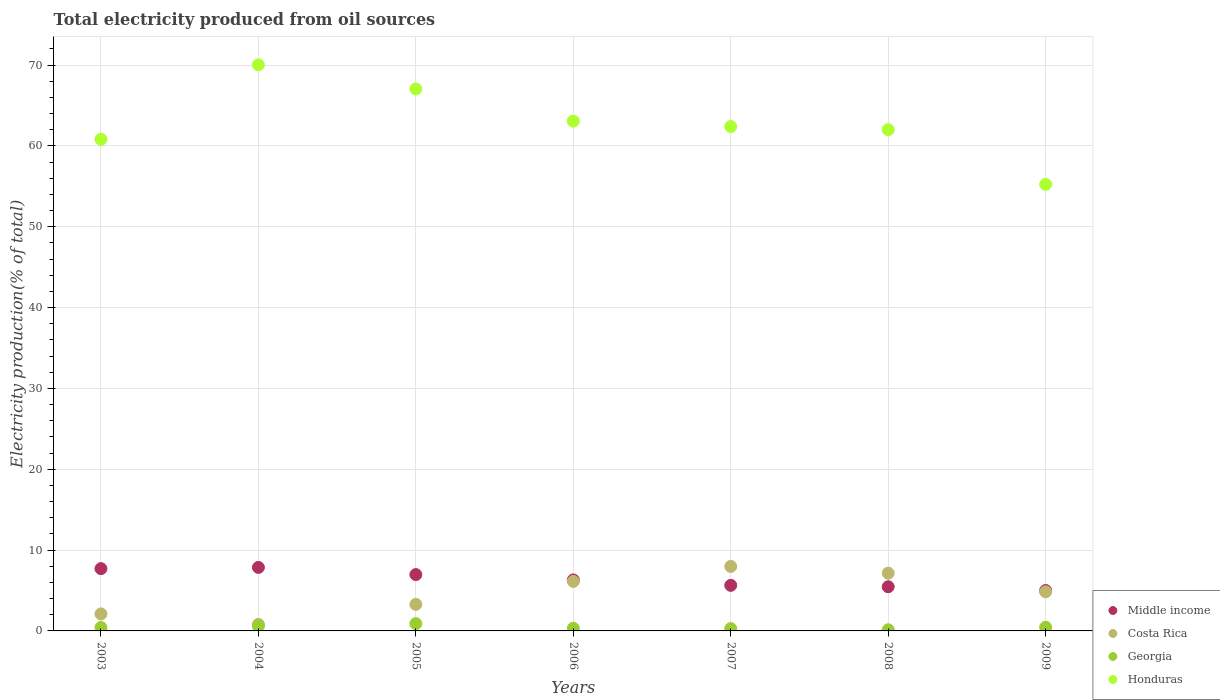Is the number of dotlines equal to the number of legend labels?
Your response must be concise. Yes. What is the total electricity produced in Georgia in 2005?
Your answer should be compact. 0.91. Across all years, what is the maximum total electricity produced in Costa Rica?
Your response must be concise. 7.98. Across all years, what is the minimum total electricity produced in Costa Rica?
Give a very brief answer. 0.8. In which year was the total electricity produced in Georgia minimum?
Provide a succinct answer. 2008. What is the total total electricity produced in Georgia in the graph?
Your answer should be very brief. 3.15. What is the difference between the total electricity produced in Georgia in 2004 and that in 2005?
Make the answer very short. -0.3. What is the difference between the total electricity produced in Costa Rica in 2003 and the total electricity produced in Middle income in 2007?
Give a very brief answer. -3.53. What is the average total electricity produced in Honduras per year?
Your answer should be very brief. 62.95. In the year 2003, what is the difference between the total electricity produced in Honduras and total electricity produced in Middle income?
Your answer should be compact. 53.12. In how many years, is the total electricity produced in Honduras greater than 10 %?
Ensure brevity in your answer.  7. What is the ratio of the total electricity produced in Costa Rica in 2004 to that in 2008?
Your answer should be very brief. 0.11. What is the difference between the highest and the second highest total electricity produced in Middle income?
Your answer should be very brief. 0.15. What is the difference between the highest and the lowest total electricity produced in Middle income?
Provide a succinct answer. 2.85. In how many years, is the total electricity produced in Middle income greater than the average total electricity produced in Middle income taken over all years?
Offer a very short reply. 3. Is it the case that in every year, the sum of the total electricity produced in Middle income and total electricity produced in Honduras  is greater than the sum of total electricity produced in Georgia and total electricity produced in Costa Rica?
Give a very brief answer. Yes. Does the total electricity produced in Georgia monotonically increase over the years?
Provide a short and direct response. No. Is the total electricity produced in Costa Rica strictly less than the total electricity produced in Honduras over the years?
Give a very brief answer. Yes. How many dotlines are there?
Your answer should be compact. 4. Are the values on the major ticks of Y-axis written in scientific E-notation?
Make the answer very short. No. Does the graph contain any zero values?
Provide a succinct answer. No. Does the graph contain grids?
Give a very brief answer. Yes. Where does the legend appear in the graph?
Your answer should be compact. Bottom right. How many legend labels are there?
Your answer should be compact. 4. How are the legend labels stacked?
Your answer should be compact. Vertical. What is the title of the graph?
Your answer should be compact. Total electricity produced from oil sources. What is the label or title of the X-axis?
Offer a terse response. Years. What is the Electricity production(% of total) in Middle income in 2003?
Your response must be concise. 7.7. What is the Electricity production(% of total) in Costa Rica in 2003?
Offer a very short reply. 2.11. What is the Electricity production(% of total) in Georgia in 2003?
Ensure brevity in your answer.  0.42. What is the Electricity production(% of total) in Honduras in 2003?
Offer a terse response. 60.82. What is the Electricity production(% of total) in Middle income in 2004?
Offer a very short reply. 7.86. What is the Electricity production(% of total) in Costa Rica in 2004?
Ensure brevity in your answer.  0.8. What is the Electricity production(% of total) in Georgia in 2004?
Your answer should be compact. 0.61. What is the Electricity production(% of total) in Honduras in 2004?
Your answer should be very brief. 70.03. What is the Electricity production(% of total) of Middle income in 2005?
Offer a terse response. 6.97. What is the Electricity production(% of total) of Costa Rica in 2005?
Make the answer very short. 3.28. What is the Electricity production(% of total) of Georgia in 2005?
Provide a succinct answer. 0.91. What is the Electricity production(% of total) of Honduras in 2005?
Your answer should be compact. 67.05. What is the Electricity production(% of total) in Middle income in 2006?
Your answer should be compact. 6.31. What is the Electricity production(% of total) in Costa Rica in 2006?
Provide a succinct answer. 6.13. What is the Electricity production(% of total) in Georgia in 2006?
Provide a succinct answer. 0.33. What is the Electricity production(% of total) in Honduras in 2006?
Offer a terse response. 63.07. What is the Electricity production(% of total) in Middle income in 2007?
Ensure brevity in your answer.  5.64. What is the Electricity production(% of total) of Costa Rica in 2007?
Offer a very short reply. 7.98. What is the Electricity production(% of total) in Georgia in 2007?
Your answer should be compact. 0.29. What is the Electricity production(% of total) of Honduras in 2007?
Keep it short and to the point. 62.4. What is the Electricity production(% of total) in Middle income in 2008?
Your answer should be compact. 5.47. What is the Electricity production(% of total) of Costa Rica in 2008?
Your answer should be very brief. 7.15. What is the Electricity production(% of total) in Georgia in 2008?
Your answer should be very brief. 0.14. What is the Electricity production(% of total) of Honduras in 2008?
Give a very brief answer. 62.01. What is the Electricity production(% of total) in Middle income in 2009?
Make the answer very short. 5. What is the Electricity production(% of total) of Costa Rica in 2009?
Your response must be concise. 4.84. What is the Electricity production(% of total) of Georgia in 2009?
Your response must be concise. 0.46. What is the Electricity production(% of total) in Honduras in 2009?
Offer a terse response. 55.25. Across all years, what is the maximum Electricity production(% of total) in Middle income?
Offer a terse response. 7.86. Across all years, what is the maximum Electricity production(% of total) in Costa Rica?
Ensure brevity in your answer.  7.98. Across all years, what is the maximum Electricity production(% of total) in Georgia?
Ensure brevity in your answer.  0.91. Across all years, what is the maximum Electricity production(% of total) in Honduras?
Your answer should be compact. 70.03. Across all years, what is the minimum Electricity production(% of total) in Middle income?
Offer a terse response. 5. Across all years, what is the minimum Electricity production(% of total) of Costa Rica?
Provide a succinct answer. 0.8. Across all years, what is the minimum Electricity production(% of total) in Georgia?
Provide a short and direct response. 0.14. Across all years, what is the minimum Electricity production(% of total) of Honduras?
Keep it short and to the point. 55.25. What is the total Electricity production(% of total) of Middle income in the graph?
Your response must be concise. 44.95. What is the total Electricity production(% of total) of Costa Rica in the graph?
Give a very brief answer. 32.29. What is the total Electricity production(% of total) in Georgia in the graph?
Offer a terse response. 3.15. What is the total Electricity production(% of total) in Honduras in the graph?
Your response must be concise. 440.64. What is the difference between the Electricity production(% of total) in Middle income in 2003 and that in 2004?
Ensure brevity in your answer.  -0.15. What is the difference between the Electricity production(% of total) of Costa Rica in 2003 and that in 2004?
Make the answer very short. 1.3. What is the difference between the Electricity production(% of total) of Georgia in 2003 and that in 2004?
Make the answer very short. -0.19. What is the difference between the Electricity production(% of total) of Honduras in 2003 and that in 2004?
Your answer should be very brief. -9.21. What is the difference between the Electricity production(% of total) in Middle income in 2003 and that in 2005?
Your answer should be compact. 0.73. What is the difference between the Electricity production(% of total) in Costa Rica in 2003 and that in 2005?
Provide a short and direct response. -1.17. What is the difference between the Electricity production(% of total) of Georgia in 2003 and that in 2005?
Provide a succinct answer. -0.49. What is the difference between the Electricity production(% of total) in Honduras in 2003 and that in 2005?
Offer a terse response. -6.23. What is the difference between the Electricity production(% of total) in Middle income in 2003 and that in 2006?
Ensure brevity in your answer.  1.4. What is the difference between the Electricity production(% of total) in Costa Rica in 2003 and that in 2006?
Give a very brief answer. -4.02. What is the difference between the Electricity production(% of total) of Georgia in 2003 and that in 2006?
Make the answer very short. 0.09. What is the difference between the Electricity production(% of total) of Honduras in 2003 and that in 2006?
Provide a succinct answer. -2.25. What is the difference between the Electricity production(% of total) of Middle income in 2003 and that in 2007?
Keep it short and to the point. 2.07. What is the difference between the Electricity production(% of total) of Costa Rica in 2003 and that in 2007?
Keep it short and to the point. -5.87. What is the difference between the Electricity production(% of total) of Georgia in 2003 and that in 2007?
Provide a succinct answer. 0.13. What is the difference between the Electricity production(% of total) in Honduras in 2003 and that in 2007?
Offer a very short reply. -1.57. What is the difference between the Electricity production(% of total) in Middle income in 2003 and that in 2008?
Ensure brevity in your answer.  2.24. What is the difference between the Electricity production(% of total) in Costa Rica in 2003 and that in 2008?
Provide a succinct answer. -5.04. What is the difference between the Electricity production(% of total) of Georgia in 2003 and that in 2008?
Provide a succinct answer. 0.28. What is the difference between the Electricity production(% of total) in Honduras in 2003 and that in 2008?
Offer a very short reply. -1.19. What is the difference between the Electricity production(% of total) in Middle income in 2003 and that in 2009?
Ensure brevity in your answer.  2.7. What is the difference between the Electricity production(% of total) of Costa Rica in 2003 and that in 2009?
Offer a very short reply. -2.74. What is the difference between the Electricity production(% of total) in Georgia in 2003 and that in 2009?
Offer a terse response. -0.04. What is the difference between the Electricity production(% of total) of Honduras in 2003 and that in 2009?
Keep it short and to the point. 5.58. What is the difference between the Electricity production(% of total) in Middle income in 2004 and that in 2005?
Ensure brevity in your answer.  0.88. What is the difference between the Electricity production(% of total) in Costa Rica in 2004 and that in 2005?
Offer a very short reply. -2.48. What is the difference between the Electricity production(% of total) of Georgia in 2004 and that in 2005?
Your answer should be very brief. -0.3. What is the difference between the Electricity production(% of total) of Honduras in 2004 and that in 2005?
Your answer should be compact. 2.98. What is the difference between the Electricity production(% of total) of Middle income in 2004 and that in 2006?
Make the answer very short. 1.55. What is the difference between the Electricity production(% of total) of Costa Rica in 2004 and that in 2006?
Your answer should be very brief. -5.33. What is the difference between the Electricity production(% of total) in Georgia in 2004 and that in 2006?
Your response must be concise. 0.28. What is the difference between the Electricity production(% of total) in Honduras in 2004 and that in 2006?
Offer a very short reply. 6.96. What is the difference between the Electricity production(% of total) of Middle income in 2004 and that in 2007?
Give a very brief answer. 2.22. What is the difference between the Electricity production(% of total) in Costa Rica in 2004 and that in 2007?
Your response must be concise. -7.17. What is the difference between the Electricity production(% of total) in Georgia in 2004 and that in 2007?
Your response must be concise. 0.32. What is the difference between the Electricity production(% of total) in Honduras in 2004 and that in 2007?
Give a very brief answer. 7.63. What is the difference between the Electricity production(% of total) of Middle income in 2004 and that in 2008?
Your response must be concise. 2.39. What is the difference between the Electricity production(% of total) in Costa Rica in 2004 and that in 2008?
Offer a terse response. -6.34. What is the difference between the Electricity production(% of total) of Georgia in 2004 and that in 2008?
Your answer should be very brief. 0.46. What is the difference between the Electricity production(% of total) in Honduras in 2004 and that in 2008?
Offer a very short reply. 8.02. What is the difference between the Electricity production(% of total) in Middle income in 2004 and that in 2009?
Give a very brief answer. 2.85. What is the difference between the Electricity production(% of total) in Costa Rica in 2004 and that in 2009?
Your response must be concise. -4.04. What is the difference between the Electricity production(% of total) in Georgia in 2004 and that in 2009?
Your answer should be compact. 0.15. What is the difference between the Electricity production(% of total) in Honduras in 2004 and that in 2009?
Make the answer very short. 14.79. What is the difference between the Electricity production(% of total) of Middle income in 2005 and that in 2006?
Provide a short and direct response. 0.66. What is the difference between the Electricity production(% of total) of Costa Rica in 2005 and that in 2006?
Provide a short and direct response. -2.85. What is the difference between the Electricity production(% of total) in Georgia in 2005 and that in 2006?
Make the answer very short. 0.58. What is the difference between the Electricity production(% of total) in Honduras in 2005 and that in 2006?
Ensure brevity in your answer.  3.98. What is the difference between the Electricity production(% of total) of Middle income in 2005 and that in 2007?
Keep it short and to the point. 1.33. What is the difference between the Electricity production(% of total) of Costa Rica in 2005 and that in 2007?
Your answer should be very brief. -4.7. What is the difference between the Electricity production(% of total) in Georgia in 2005 and that in 2007?
Keep it short and to the point. 0.62. What is the difference between the Electricity production(% of total) of Honduras in 2005 and that in 2007?
Make the answer very short. 4.65. What is the difference between the Electricity production(% of total) in Middle income in 2005 and that in 2008?
Your response must be concise. 1.51. What is the difference between the Electricity production(% of total) in Costa Rica in 2005 and that in 2008?
Your answer should be compact. -3.86. What is the difference between the Electricity production(% of total) in Georgia in 2005 and that in 2008?
Offer a very short reply. 0.77. What is the difference between the Electricity production(% of total) of Honduras in 2005 and that in 2008?
Offer a very short reply. 5.04. What is the difference between the Electricity production(% of total) in Middle income in 2005 and that in 2009?
Offer a terse response. 1.97. What is the difference between the Electricity production(% of total) in Costa Rica in 2005 and that in 2009?
Make the answer very short. -1.56. What is the difference between the Electricity production(% of total) in Georgia in 2005 and that in 2009?
Give a very brief answer. 0.45. What is the difference between the Electricity production(% of total) of Honduras in 2005 and that in 2009?
Provide a short and direct response. 11.81. What is the difference between the Electricity production(% of total) in Middle income in 2006 and that in 2007?
Provide a short and direct response. 0.67. What is the difference between the Electricity production(% of total) of Costa Rica in 2006 and that in 2007?
Provide a succinct answer. -1.85. What is the difference between the Electricity production(% of total) in Georgia in 2006 and that in 2007?
Ensure brevity in your answer.  0.04. What is the difference between the Electricity production(% of total) of Honduras in 2006 and that in 2007?
Provide a succinct answer. 0.67. What is the difference between the Electricity production(% of total) of Middle income in 2006 and that in 2008?
Give a very brief answer. 0.84. What is the difference between the Electricity production(% of total) in Costa Rica in 2006 and that in 2008?
Offer a terse response. -1.02. What is the difference between the Electricity production(% of total) in Georgia in 2006 and that in 2008?
Your response must be concise. 0.19. What is the difference between the Electricity production(% of total) of Honduras in 2006 and that in 2008?
Your answer should be very brief. 1.06. What is the difference between the Electricity production(% of total) of Middle income in 2006 and that in 2009?
Provide a short and direct response. 1.3. What is the difference between the Electricity production(% of total) in Costa Rica in 2006 and that in 2009?
Make the answer very short. 1.28. What is the difference between the Electricity production(% of total) of Georgia in 2006 and that in 2009?
Provide a short and direct response. -0.13. What is the difference between the Electricity production(% of total) in Honduras in 2006 and that in 2009?
Offer a terse response. 7.83. What is the difference between the Electricity production(% of total) of Middle income in 2007 and that in 2008?
Keep it short and to the point. 0.17. What is the difference between the Electricity production(% of total) in Costa Rica in 2007 and that in 2008?
Your answer should be very brief. 0.83. What is the difference between the Electricity production(% of total) in Georgia in 2007 and that in 2008?
Give a very brief answer. 0.15. What is the difference between the Electricity production(% of total) in Honduras in 2007 and that in 2008?
Your answer should be very brief. 0.39. What is the difference between the Electricity production(% of total) of Middle income in 2007 and that in 2009?
Provide a succinct answer. 0.63. What is the difference between the Electricity production(% of total) of Costa Rica in 2007 and that in 2009?
Give a very brief answer. 3.13. What is the difference between the Electricity production(% of total) in Georgia in 2007 and that in 2009?
Offer a very short reply. -0.17. What is the difference between the Electricity production(% of total) in Honduras in 2007 and that in 2009?
Provide a short and direct response. 7.15. What is the difference between the Electricity production(% of total) in Middle income in 2008 and that in 2009?
Your answer should be very brief. 0.46. What is the difference between the Electricity production(% of total) in Costa Rica in 2008 and that in 2009?
Your response must be concise. 2.3. What is the difference between the Electricity production(% of total) in Georgia in 2008 and that in 2009?
Offer a very short reply. -0.31. What is the difference between the Electricity production(% of total) of Honduras in 2008 and that in 2009?
Provide a succinct answer. 6.76. What is the difference between the Electricity production(% of total) in Middle income in 2003 and the Electricity production(% of total) in Costa Rica in 2004?
Offer a very short reply. 6.9. What is the difference between the Electricity production(% of total) in Middle income in 2003 and the Electricity production(% of total) in Georgia in 2004?
Your answer should be very brief. 7.1. What is the difference between the Electricity production(% of total) in Middle income in 2003 and the Electricity production(% of total) in Honduras in 2004?
Your answer should be very brief. -62.33. What is the difference between the Electricity production(% of total) in Costa Rica in 2003 and the Electricity production(% of total) in Georgia in 2004?
Provide a short and direct response. 1.5. What is the difference between the Electricity production(% of total) in Costa Rica in 2003 and the Electricity production(% of total) in Honduras in 2004?
Your response must be concise. -67.93. What is the difference between the Electricity production(% of total) of Georgia in 2003 and the Electricity production(% of total) of Honduras in 2004?
Make the answer very short. -69.61. What is the difference between the Electricity production(% of total) of Middle income in 2003 and the Electricity production(% of total) of Costa Rica in 2005?
Offer a very short reply. 4.42. What is the difference between the Electricity production(% of total) of Middle income in 2003 and the Electricity production(% of total) of Georgia in 2005?
Provide a succinct answer. 6.8. What is the difference between the Electricity production(% of total) in Middle income in 2003 and the Electricity production(% of total) in Honduras in 2005?
Provide a succinct answer. -59.35. What is the difference between the Electricity production(% of total) of Costa Rica in 2003 and the Electricity production(% of total) of Georgia in 2005?
Your response must be concise. 1.2. What is the difference between the Electricity production(% of total) in Costa Rica in 2003 and the Electricity production(% of total) in Honduras in 2005?
Your answer should be very brief. -64.95. What is the difference between the Electricity production(% of total) in Georgia in 2003 and the Electricity production(% of total) in Honduras in 2005?
Your answer should be compact. -66.63. What is the difference between the Electricity production(% of total) in Middle income in 2003 and the Electricity production(% of total) in Costa Rica in 2006?
Your answer should be compact. 1.58. What is the difference between the Electricity production(% of total) in Middle income in 2003 and the Electricity production(% of total) in Georgia in 2006?
Provide a short and direct response. 7.38. What is the difference between the Electricity production(% of total) in Middle income in 2003 and the Electricity production(% of total) in Honduras in 2006?
Ensure brevity in your answer.  -55.37. What is the difference between the Electricity production(% of total) of Costa Rica in 2003 and the Electricity production(% of total) of Georgia in 2006?
Your answer should be compact. 1.78. What is the difference between the Electricity production(% of total) of Costa Rica in 2003 and the Electricity production(% of total) of Honduras in 2006?
Keep it short and to the point. -60.97. What is the difference between the Electricity production(% of total) in Georgia in 2003 and the Electricity production(% of total) in Honduras in 2006?
Make the answer very short. -62.65. What is the difference between the Electricity production(% of total) of Middle income in 2003 and the Electricity production(% of total) of Costa Rica in 2007?
Ensure brevity in your answer.  -0.27. What is the difference between the Electricity production(% of total) in Middle income in 2003 and the Electricity production(% of total) in Georgia in 2007?
Provide a short and direct response. 7.42. What is the difference between the Electricity production(% of total) of Middle income in 2003 and the Electricity production(% of total) of Honduras in 2007?
Your answer should be very brief. -54.69. What is the difference between the Electricity production(% of total) in Costa Rica in 2003 and the Electricity production(% of total) in Georgia in 2007?
Ensure brevity in your answer.  1.82. What is the difference between the Electricity production(% of total) in Costa Rica in 2003 and the Electricity production(% of total) in Honduras in 2007?
Make the answer very short. -60.29. What is the difference between the Electricity production(% of total) of Georgia in 2003 and the Electricity production(% of total) of Honduras in 2007?
Offer a terse response. -61.98. What is the difference between the Electricity production(% of total) of Middle income in 2003 and the Electricity production(% of total) of Costa Rica in 2008?
Ensure brevity in your answer.  0.56. What is the difference between the Electricity production(% of total) in Middle income in 2003 and the Electricity production(% of total) in Georgia in 2008?
Give a very brief answer. 7.56. What is the difference between the Electricity production(% of total) in Middle income in 2003 and the Electricity production(% of total) in Honduras in 2008?
Make the answer very short. -54.3. What is the difference between the Electricity production(% of total) of Costa Rica in 2003 and the Electricity production(% of total) of Georgia in 2008?
Keep it short and to the point. 1.96. What is the difference between the Electricity production(% of total) in Costa Rica in 2003 and the Electricity production(% of total) in Honduras in 2008?
Your answer should be very brief. -59.9. What is the difference between the Electricity production(% of total) of Georgia in 2003 and the Electricity production(% of total) of Honduras in 2008?
Give a very brief answer. -61.59. What is the difference between the Electricity production(% of total) in Middle income in 2003 and the Electricity production(% of total) in Costa Rica in 2009?
Your response must be concise. 2.86. What is the difference between the Electricity production(% of total) of Middle income in 2003 and the Electricity production(% of total) of Georgia in 2009?
Your response must be concise. 7.25. What is the difference between the Electricity production(% of total) in Middle income in 2003 and the Electricity production(% of total) in Honduras in 2009?
Provide a succinct answer. -47.54. What is the difference between the Electricity production(% of total) in Costa Rica in 2003 and the Electricity production(% of total) in Georgia in 2009?
Ensure brevity in your answer.  1.65. What is the difference between the Electricity production(% of total) of Costa Rica in 2003 and the Electricity production(% of total) of Honduras in 2009?
Offer a terse response. -53.14. What is the difference between the Electricity production(% of total) of Georgia in 2003 and the Electricity production(% of total) of Honduras in 2009?
Your response must be concise. -54.83. What is the difference between the Electricity production(% of total) in Middle income in 2004 and the Electricity production(% of total) in Costa Rica in 2005?
Make the answer very short. 4.58. What is the difference between the Electricity production(% of total) in Middle income in 2004 and the Electricity production(% of total) in Georgia in 2005?
Your answer should be compact. 6.95. What is the difference between the Electricity production(% of total) of Middle income in 2004 and the Electricity production(% of total) of Honduras in 2005?
Provide a short and direct response. -59.2. What is the difference between the Electricity production(% of total) of Costa Rica in 2004 and the Electricity production(% of total) of Georgia in 2005?
Provide a succinct answer. -0.1. What is the difference between the Electricity production(% of total) of Costa Rica in 2004 and the Electricity production(% of total) of Honduras in 2005?
Make the answer very short. -66.25. What is the difference between the Electricity production(% of total) in Georgia in 2004 and the Electricity production(% of total) in Honduras in 2005?
Make the answer very short. -66.45. What is the difference between the Electricity production(% of total) in Middle income in 2004 and the Electricity production(% of total) in Costa Rica in 2006?
Your answer should be very brief. 1.73. What is the difference between the Electricity production(% of total) in Middle income in 2004 and the Electricity production(% of total) in Georgia in 2006?
Your response must be concise. 7.53. What is the difference between the Electricity production(% of total) of Middle income in 2004 and the Electricity production(% of total) of Honduras in 2006?
Offer a terse response. -55.22. What is the difference between the Electricity production(% of total) in Costa Rica in 2004 and the Electricity production(% of total) in Georgia in 2006?
Give a very brief answer. 0.47. What is the difference between the Electricity production(% of total) in Costa Rica in 2004 and the Electricity production(% of total) in Honduras in 2006?
Keep it short and to the point. -62.27. What is the difference between the Electricity production(% of total) in Georgia in 2004 and the Electricity production(% of total) in Honduras in 2006?
Your answer should be very brief. -62.47. What is the difference between the Electricity production(% of total) in Middle income in 2004 and the Electricity production(% of total) in Costa Rica in 2007?
Keep it short and to the point. -0.12. What is the difference between the Electricity production(% of total) of Middle income in 2004 and the Electricity production(% of total) of Georgia in 2007?
Provide a short and direct response. 7.57. What is the difference between the Electricity production(% of total) of Middle income in 2004 and the Electricity production(% of total) of Honduras in 2007?
Give a very brief answer. -54.54. What is the difference between the Electricity production(% of total) in Costa Rica in 2004 and the Electricity production(% of total) in Georgia in 2007?
Provide a succinct answer. 0.52. What is the difference between the Electricity production(% of total) in Costa Rica in 2004 and the Electricity production(% of total) in Honduras in 2007?
Make the answer very short. -61.6. What is the difference between the Electricity production(% of total) of Georgia in 2004 and the Electricity production(% of total) of Honduras in 2007?
Give a very brief answer. -61.79. What is the difference between the Electricity production(% of total) of Middle income in 2004 and the Electricity production(% of total) of Costa Rica in 2008?
Offer a terse response. 0.71. What is the difference between the Electricity production(% of total) of Middle income in 2004 and the Electricity production(% of total) of Georgia in 2008?
Provide a succinct answer. 7.71. What is the difference between the Electricity production(% of total) in Middle income in 2004 and the Electricity production(% of total) in Honduras in 2008?
Your response must be concise. -54.15. What is the difference between the Electricity production(% of total) of Costa Rica in 2004 and the Electricity production(% of total) of Georgia in 2008?
Provide a succinct answer. 0.66. What is the difference between the Electricity production(% of total) in Costa Rica in 2004 and the Electricity production(% of total) in Honduras in 2008?
Your response must be concise. -61.21. What is the difference between the Electricity production(% of total) in Georgia in 2004 and the Electricity production(% of total) in Honduras in 2008?
Your response must be concise. -61.4. What is the difference between the Electricity production(% of total) in Middle income in 2004 and the Electricity production(% of total) in Costa Rica in 2009?
Your answer should be compact. 3.01. What is the difference between the Electricity production(% of total) of Middle income in 2004 and the Electricity production(% of total) of Georgia in 2009?
Your answer should be compact. 7.4. What is the difference between the Electricity production(% of total) in Middle income in 2004 and the Electricity production(% of total) in Honduras in 2009?
Your answer should be very brief. -47.39. What is the difference between the Electricity production(% of total) in Costa Rica in 2004 and the Electricity production(% of total) in Georgia in 2009?
Make the answer very short. 0.35. What is the difference between the Electricity production(% of total) in Costa Rica in 2004 and the Electricity production(% of total) in Honduras in 2009?
Keep it short and to the point. -54.44. What is the difference between the Electricity production(% of total) in Georgia in 2004 and the Electricity production(% of total) in Honduras in 2009?
Offer a terse response. -54.64. What is the difference between the Electricity production(% of total) of Middle income in 2005 and the Electricity production(% of total) of Costa Rica in 2006?
Make the answer very short. 0.84. What is the difference between the Electricity production(% of total) of Middle income in 2005 and the Electricity production(% of total) of Georgia in 2006?
Provide a short and direct response. 6.64. What is the difference between the Electricity production(% of total) in Middle income in 2005 and the Electricity production(% of total) in Honduras in 2006?
Offer a very short reply. -56.1. What is the difference between the Electricity production(% of total) in Costa Rica in 2005 and the Electricity production(% of total) in Georgia in 2006?
Make the answer very short. 2.95. What is the difference between the Electricity production(% of total) of Costa Rica in 2005 and the Electricity production(% of total) of Honduras in 2006?
Your response must be concise. -59.79. What is the difference between the Electricity production(% of total) of Georgia in 2005 and the Electricity production(% of total) of Honduras in 2006?
Your response must be concise. -62.16. What is the difference between the Electricity production(% of total) of Middle income in 2005 and the Electricity production(% of total) of Costa Rica in 2007?
Give a very brief answer. -1.01. What is the difference between the Electricity production(% of total) of Middle income in 2005 and the Electricity production(% of total) of Georgia in 2007?
Your answer should be very brief. 6.68. What is the difference between the Electricity production(% of total) in Middle income in 2005 and the Electricity production(% of total) in Honduras in 2007?
Your response must be concise. -55.43. What is the difference between the Electricity production(% of total) of Costa Rica in 2005 and the Electricity production(% of total) of Georgia in 2007?
Ensure brevity in your answer.  2.99. What is the difference between the Electricity production(% of total) in Costa Rica in 2005 and the Electricity production(% of total) in Honduras in 2007?
Make the answer very short. -59.12. What is the difference between the Electricity production(% of total) in Georgia in 2005 and the Electricity production(% of total) in Honduras in 2007?
Offer a terse response. -61.49. What is the difference between the Electricity production(% of total) in Middle income in 2005 and the Electricity production(% of total) in Costa Rica in 2008?
Provide a short and direct response. -0.17. What is the difference between the Electricity production(% of total) in Middle income in 2005 and the Electricity production(% of total) in Georgia in 2008?
Provide a succinct answer. 6.83. What is the difference between the Electricity production(% of total) in Middle income in 2005 and the Electricity production(% of total) in Honduras in 2008?
Ensure brevity in your answer.  -55.04. What is the difference between the Electricity production(% of total) of Costa Rica in 2005 and the Electricity production(% of total) of Georgia in 2008?
Make the answer very short. 3.14. What is the difference between the Electricity production(% of total) of Costa Rica in 2005 and the Electricity production(% of total) of Honduras in 2008?
Your answer should be very brief. -58.73. What is the difference between the Electricity production(% of total) in Georgia in 2005 and the Electricity production(% of total) in Honduras in 2008?
Your answer should be compact. -61.1. What is the difference between the Electricity production(% of total) of Middle income in 2005 and the Electricity production(% of total) of Costa Rica in 2009?
Your answer should be compact. 2.13. What is the difference between the Electricity production(% of total) of Middle income in 2005 and the Electricity production(% of total) of Georgia in 2009?
Keep it short and to the point. 6.52. What is the difference between the Electricity production(% of total) in Middle income in 2005 and the Electricity production(% of total) in Honduras in 2009?
Provide a succinct answer. -48.27. What is the difference between the Electricity production(% of total) of Costa Rica in 2005 and the Electricity production(% of total) of Georgia in 2009?
Keep it short and to the point. 2.83. What is the difference between the Electricity production(% of total) in Costa Rica in 2005 and the Electricity production(% of total) in Honduras in 2009?
Your answer should be very brief. -51.96. What is the difference between the Electricity production(% of total) in Georgia in 2005 and the Electricity production(% of total) in Honduras in 2009?
Make the answer very short. -54.34. What is the difference between the Electricity production(% of total) in Middle income in 2006 and the Electricity production(% of total) in Costa Rica in 2007?
Offer a terse response. -1.67. What is the difference between the Electricity production(% of total) of Middle income in 2006 and the Electricity production(% of total) of Georgia in 2007?
Provide a succinct answer. 6.02. What is the difference between the Electricity production(% of total) of Middle income in 2006 and the Electricity production(% of total) of Honduras in 2007?
Your response must be concise. -56.09. What is the difference between the Electricity production(% of total) of Costa Rica in 2006 and the Electricity production(% of total) of Georgia in 2007?
Keep it short and to the point. 5.84. What is the difference between the Electricity production(% of total) in Costa Rica in 2006 and the Electricity production(% of total) in Honduras in 2007?
Your answer should be very brief. -56.27. What is the difference between the Electricity production(% of total) of Georgia in 2006 and the Electricity production(% of total) of Honduras in 2007?
Your response must be concise. -62.07. What is the difference between the Electricity production(% of total) of Middle income in 2006 and the Electricity production(% of total) of Costa Rica in 2008?
Provide a succinct answer. -0.84. What is the difference between the Electricity production(% of total) of Middle income in 2006 and the Electricity production(% of total) of Georgia in 2008?
Keep it short and to the point. 6.17. What is the difference between the Electricity production(% of total) of Middle income in 2006 and the Electricity production(% of total) of Honduras in 2008?
Your response must be concise. -55.7. What is the difference between the Electricity production(% of total) in Costa Rica in 2006 and the Electricity production(% of total) in Georgia in 2008?
Ensure brevity in your answer.  5.99. What is the difference between the Electricity production(% of total) in Costa Rica in 2006 and the Electricity production(% of total) in Honduras in 2008?
Provide a succinct answer. -55.88. What is the difference between the Electricity production(% of total) of Georgia in 2006 and the Electricity production(% of total) of Honduras in 2008?
Ensure brevity in your answer.  -61.68. What is the difference between the Electricity production(% of total) of Middle income in 2006 and the Electricity production(% of total) of Costa Rica in 2009?
Your response must be concise. 1.47. What is the difference between the Electricity production(% of total) of Middle income in 2006 and the Electricity production(% of total) of Georgia in 2009?
Your answer should be very brief. 5.85. What is the difference between the Electricity production(% of total) of Middle income in 2006 and the Electricity production(% of total) of Honduras in 2009?
Your answer should be compact. -48.94. What is the difference between the Electricity production(% of total) in Costa Rica in 2006 and the Electricity production(% of total) in Georgia in 2009?
Your answer should be very brief. 5.67. What is the difference between the Electricity production(% of total) in Costa Rica in 2006 and the Electricity production(% of total) in Honduras in 2009?
Provide a succinct answer. -49.12. What is the difference between the Electricity production(% of total) in Georgia in 2006 and the Electricity production(% of total) in Honduras in 2009?
Provide a short and direct response. -54.92. What is the difference between the Electricity production(% of total) of Middle income in 2007 and the Electricity production(% of total) of Costa Rica in 2008?
Your response must be concise. -1.51. What is the difference between the Electricity production(% of total) of Middle income in 2007 and the Electricity production(% of total) of Georgia in 2008?
Keep it short and to the point. 5.5. What is the difference between the Electricity production(% of total) in Middle income in 2007 and the Electricity production(% of total) in Honduras in 2008?
Your answer should be very brief. -56.37. What is the difference between the Electricity production(% of total) of Costa Rica in 2007 and the Electricity production(% of total) of Georgia in 2008?
Offer a very short reply. 7.84. What is the difference between the Electricity production(% of total) in Costa Rica in 2007 and the Electricity production(% of total) in Honduras in 2008?
Your response must be concise. -54.03. What is the difference between the Electricity production(% of total) in Georgia in 2007 and the Electricity production(% of total) in Honduras in 2008?
Your response must be concise. -61.72. What is the difference between the Electricity production(% of total) in Middle income in 2007 and the Electricity production(% of total) in Costa Rica in 2009?
Offer a terse response. 0.79. What is the difference between the Electricity production(% of total) in Middle income in 2007 and the Electricity production(% of total) in Georgia in 2009?
Offer a very short reply. 5.18. What is the difference between the Electricity production(% of total) of Middle income in 2007 and the Electricity production(% of total) of Honduras in 2009?
Make the answer very short. -49.61. What is the difference between the Electricity production(% of total) of Costa Rica in 2007 and the Electricity production(% of total) of Georgia in 2009?
Make the answer very short. 7.52. What is the difference between the Electricity production(% of total) of Costa Rica in 2007 and the Electricity production(% of total) of Honduras in 2009?
Your answer should be compact. -47.27. What is the difference between the Electricity production(% of total) of Georgia in 2007 and the Electricity production(% of total) of Honduras in 2009?
Give a very brief answer. -54.96. What is the difference between the Electricity production(% of total) in Middle income in 2008 and the Electricity production(% of total) in Costa Rica in 2009?
Make the answer very short. 0.62. What is the difference between the Electricity production(% of total) in Middle income in 2008 and the Electricity production(% of total) in Georgia in 2009?
Your answer should be compact. 5.01. What is the difference between the Electricity production(% of total) in Middle income in 2008 and the Electricity production(% of total) in Honduras in 2009?
Provide a succinct answer. -49.78. What is the difference between the Electricity production(% of total) in Costa Rica in 2008 and the Electricity production(% of total) in Georgia in 2009?
Give a very brief answer. 6.69. What is the difference between the Electricity production(% of total) in Costa Rica in 2008 and the Electricity production(% of total) in Honduras in 2009?
Offer a very short reply. -48.1. What is the difference between the Electricity production(% of total) in Georgia in 2008 and the Electricity production(% of total) in Honduras in 2009?
Keep it short and to the point. -55.1. What is the average Electricity production(% of total) in Middle income per year?
Your answer should be compact. 6.42. What is the average Electricity production(% of total) in Costa Rica per year?
Provide a short and direct response. 4.61. What is the average Electricity production(% of total) of Georgia per year?
Offer a terse response. 0.45. What is the average Electricity production(% of total) of Honduras per year?
Your response must be concise. 62.95. In the year 2003, what is the difference between the Electricity production(% of total) of Middle income and Electricity production(% of total) of Costa Rica?
Provide a short and direct response. 5.6. In the year 2003, what is the difference between the Electricity production(% of total) in Middle income and Electricity production(% of total) in Georgia?
Your response must be concise. 7.29. In the year 2003, what is the difference between the Electricity production(% of total) in Middle income and Electricity production(% of total) in Honduras?
Your answer should be compact. -53.12. In the year 2003, what is the difference between the Electricity production(% of total) of Costa Rica and Electricity production(% of total) of Georgia?
Provide a succinct answer. 1.69. In the year 2003, what is the difference between the Electricity production(% of total) of Costa Rica and Electricity production(% of total) of Honduras?
Offer a terse response. -58.72. In the year 2003, what is the difference between the Electricity production(% of total) in Georgia and Electricity production(% of total) in Honduras?
Offer a very short reply. -60.41. In the year 2004, what is the difference between the Electricity production(% of total) of Middle income and Electricity production(% of total) of Costa Rica?
Provide a succinct answer. 7.05. In the year 2004, what is the difference between the Electricity production(% of total) in Middle income and Electricity production(% of total) in Georgia?
Ensure brevity in your answer.  7.25. In the year 2004, what is the difference between the Electricity production(% of total) of Middle income and Electricity production(% of total) of Honduras?
Keep it short and to the point. -62.18. In the year 2004, what is the difference between the Electricity production(% of total) in Costa Rica and Electricity production(% of total) in Georgia?
Offer a terse response. 0.2. In the year 2004, what is the difference between the Electricity production(% of total) in Costa Rica and Electricity production(% of total) in Honduras?
Your response must be concise. -69.23. In the year 2004, what is the difference between the Electricity production(% of total) of Georgia and Electricity production(% of total) of Honduras?
Your answer should be compact. -69.43. In the year 2005, what is the difference between the Electricity production(% of total) of Middle income and Electricity production(% of total) of Costa Rica?
Your response must be concise. 3.69. In the year 2005, what is the difference between the Electricity production(% of total) in Middle income and Electricity production(% of total) in Georgia?
Offer a very short reply. 6.06. In the year 2005, what is the difference between the Electricity production(% of total) of Middle income and Electricity production(% of total) of Honduras?
Offer a very short reply. -60.08. In the year 2005, what is the difference between the Electricity production(% of total) of Costa Rica and Electricity production(% of total) of Georgia?
Ensure brevity in your answer.  2.37. In the year 2005, what is the difference between the Electricity production(% of total) of Costa Rica and Electricity production(% of total) of Honduras?
Keep it short and to the point. -63.77. In the year 2005, what is the difference between the Electricity production(% of total) of Georgia and Electricity production(% of total) of Honduras?
Offer a terse response. -66.15. In the year 2006, what is the difference between the Electricity production(% of total) of Middle income and Electricity production(% of total) of Costa Rica?
Provide a succinct answer. 0.18. In the year 2006, what is the difference between the Electricity production(% of total) of Middle income and Electricity production(% of total) of Georgia?
Keep it short and to the point. 5.98. In the year 2006, what is the difference between the Electricity production(% of total) in Middle income and Electricity production(% of total) in Honduras?
Your response must be concise. -56.76. In the year 2006, what is the difference between the Electricity production(% of total) of Costa Rica and Electricity production(% of total) of Georgia?
Give a very brief answer. 5.8. In the year 2006, what is the difference between the Electricity production(% of total) of Costa Rica and Electricity production(% of total) of Honduras?
Your answer should be compact. -56.94. In the year 2006, what is the difference between the Electricity production(% of total) of Georgia and Electricity production(% of total) of Honduras?
Ensure brevity in your answer.  -62.74. In the year 2007, what is the difference between the Electricity production(% of total) in Middle income and Electricity production(% of total) in Costa Rica?
Your response must be concise. -2.34. In the year 2007, what is the difference between the Electricity production(% of total) of Middle income and Electricity production(% of total) of Georgia?
Make the answer very short. 5.35. In the year 2007, what is the difference between the Electricity production(% of total) of Middle income and Electricity production(% of total) of Honduras?
Provide a short and direct response. -56.76. In the year 2007, what is the difference between the Electricity production(% of total) in Costa Rica and Electricity production(% of total) in Georgia?
Ensure brevity in your answer.  7.69. In the year 2007, what is the difference between the Electricity production(% of total) of Costa Rica and Electricity production(% of total) of Honduras?
Give a very brief answer. -54.42. In the year 2007, what is the difference between the Electricity production(% of total) of Georgia and Electricity production(% of total) of Honduras?
Ensure brevity in your answer.  -62.11. In the year 2008, what is the difference between the Electricity production(% of total) in Middle income and Electricity production(% of total) in Costa Rica?
Provide a short and direct response. -1.68. In the year 2008, what is the difference between the Electricity production(% of total) of Middle income and Electricity production(% of total) of Georgia?
Your answer should be compact. 5.32. In the year 2008, what is the difference between the Electricity production(% of total) in Middle income and Electricity production(% of total) in Honduras?
Your answer should be compact. -56.54. In the year 2008, what is the difference between the Electricity production(% of total) in Costa Rica and Electricity production(% of total) in Georgia?
Provide a succinct answer. 7. In the year 2008, what is the difference between the Electricity production(% of total) of Costa Rica and Electricity production(% of total) of Honduras?
Provide a short and direct response. -54.86. In the year 2008, what is the difference between the Electricity production(% of total) in Georgia and Electricity production(% of total) in Honduras?
Your response must be concise. -61.87. In the year 2009, what is the difference between the Electricity production(% of total) in Middle income and Electricity production(% of total) in Costa Rica?
Your response must be concise. 0.16. In the year 2009, what is the difference between the Electricity production(% of total) in Middle income and Electricity production(% of total) in Georgia?
Offer a very short reply. 4.55. In the year 2009, what is the difference between the Electricity production(% of total) in Middle income and Electricity production(% of total) in Honduras?
Ensure brevity in your answer.  -50.24. In the year 2009, what is the difference between the Electricity production(% of total) of Costa Rica and Electricity production(% of total) of Georgia?
Make the answer very short. 4.39. In the year 2009, what is the difference between the Electricity production(% of total) in Costa Rica and Electricity production(% of total) in Honduras?
Provide a succinct answer. -50.4. In the year 2009, what is the difference between the Electricity production(% of total) in Georgia and Electricity production(% of total) in Honduras?
Offer a very short reply. -54.79. What is the ratio of the Electricity production(% of total) in Middle income in 2003 to that in 2004?
Your answer should be compact. 0.98. What is the ratio of the Electricity production(% of total) of Costa Rica in 2003 to that in 2004?
Your response must be concise. 2.62. What is the ratio of the Electricity production(% of total) in Georgia in 2003 to that in 2004?
Your answer should be compact. 0.69. What is the ratio of the Electricity production(% of total) of Honduras in 2003 to that in 2004?
Your answer should be compact. 0.87. What is the ratio of the Electricity production(% of total) of Middle income in 2003 to that in 2005?
Keep it short and to the point. 1.11. What is the ratio of the Electricity production(% of total) in Costa Rica in 2003 to that in 2005?
Provide a short and direct response. 0.64. What is the ratio of the Electricity production(% of total) of Georgia in 2003 to that in 2005?
Offer a terse response. 0.46. What is the ratio of the Electricity production(% of total) of Honduras in 2003 to that in 2005?
Your answer should be very brief. 0.91. What is the ratio of the Electricity production(% of total) of Middle income in 2003 to that in 2006?
Ensure brevity in your answer.  1.22. What is the ratio of the Electricity production(% of total) in Costa Rica in 2003 to that in 2006?
Offer a terse response. 0.34. What is the ratio of the Electricity production(% of total) in Georgia in 2003 to that in 2006?
Make the answer very short. 1.27. What is the ratio of the Electricity production(% of total) of Honduras in 2003 to that in 2006?
Provide a succinct answer. 0.96. What is the ratio of the Electricity production(% of total) in Middle income in 2003 to that in 2007?
Make the answer very short. 1.37. What is the ratio of the Electricity production(% of total) of Costa Rica in 2003 to that in 2007?
Provide a short and direct response. 0.26. What is the ratio of the Electricity production(% of total) of Georgia in 2003 to that in 2007?
Your answer should be very brief. 1.45. What is the ratio of the Electricity production(% of total) in Honduras in 2003 to that in 2007?
Your answer should be compact. 0.97. What is the ratio of the Electricity production(% of total) in Middle income in 2003 to that in 2008?
Ensure brevity in your answer.  1.41. What is the ratio of the Electricity production(% of total) in Costa Rica in 2003 to that in 2008?
Provide a succinct answer. 0.29. What is the ratio of the Electricity production(% of total) in Georgia in 2003 to that in 2008?
Make the answer very short. 2.95. What is the ratio of the Electricity production(% of total) of Honduras in 2003 to that in 2008?
Give a very brief answer. 0.98. What is the ratio of the Electricity production(% of total) in Middle income in 2003 to that in 2009?
Make the answer very short. 1.54. What is the ratio of the Electricity production(% of total) of Costa Rica in 2003 to that in 2009?
Give a very brief answer. 0.43. What is the ratio of the Electricity production(% of total) in Georgia in 2003 to that in 2009?
Ensure brevity in your answer.  0.92. What is the ratio of the Electricity production(% of total) of Honduras in 2003 to that in 2009?
Keep it short and to the point. 1.1. What is the ratio of the Electricity production(% of total) in Middle income in 2004 to that in 2005?
Give a very brief answer. 1.13. What is the ratio of the Electricity production(% of total) of Costa Rica in 2004 to that in 2005?
Your response must be concise. 0.24. What is the ratio of the Electricity production(% of total) in Georgia in 2004 to that in 2005?
Give a very brief answer. 0.67. What is the ratio of the Electricity production(% of total) of Honduras in 2004 to that in 2005?
Provide a short and direct response. 1.04. What is the ratio of the Electricity production(% of total) of Middle income in 2004 to that in 2006?
Offer a terse response. 1.25. What is the ratio of the Electricity production(% of total) in Costa Rica in 2004 to that in 2006?
Your answer should be compact. 0.13. What is the ratio of the Electricity production(% of total) in Georgia in 2004 to that in 2006?
Offer a very short reply. 1.84. What is the ratio of the Electricity production(% of total) of Honduras in 2004 to that in 2006?
Offer a very short reply. 1.11. What is the ratio of the Electricity production(% of total) of Middle income in 2004 to that in 2007?
Make the answer very short. 1.39. What is the ratio of the Electricity production(% of total) of Costa Rica in 2004 to that in 2007?
Offer a terse response. 0.1. What is the ratio of the Electricity production(% of total) of Georgia in 2004 to that in 2007?
Your answer should be compact. 2.11. What is the ratio of the Electricity production(% of total) of Honduras in 2004 to that in 2007?
Your answer should be very brief. 1.12. What is the ratio of the Electricity production(% of total) of Middle income in 2004 to that in 2008?
Your response must be concise. 1.44. What is the ratio of the Electricity production(% of total) of Costa Rica in 2004 to that in 2008?
Keep it short and to the point. 0.11. What is the ratio of the Electricity production(% of total) in Georgia in 2004 to that in 2008?
Offer a terse response. 4.27. What is the ratio of the Electricity production(% of total) of Honduras in 2004 to that in 2008?
Ensure brevity in your answer.  1.13. What is the ratio of the Electricity production(% of total) in Middle income in 2004 to that in 2009?
Your response must be concise. 1.57. What is the ratio of the Electricity production(% of total) of Costa Rica in 2004 to that in 2009?
Your answer should be compact. 0.17. What is the ratio of the Electricity production(% of total) in Georgia in 2004 to that in 2009?
Provide a short and direct response. 1.33. What is the ratio of the Electricity production(% of total) in Honduras in 2004 to that in 2009?
Provide a short and direct response. 1.27. What is the ratio of the Electricity production(% of total) of Middle income in 2005 to that in 2006?
Your response must be concise. 1.1. What is the ratio of the Electricity production(% of total) in Costa Rica in 2005 to that in 2006?
Your answer should be very brief. 0.54. What is the ratio of the Electricity production(% of total) in Georgia in 2005 to that in 2006?
Provide a succinct answer. 2.76. What is the ratio of the Electricity production(% of total) of Honduras in 2005 to that in 2006?
Offer a terse response. 1.06. What is the ratio of the Electricity production(% of total) of Middle income in 2005 to that in 2007?
Make the answer very short. 1.24. What is the ratio of the Electricity production(% of total) in Costa Rica in 2005 to that in 2007?
Make the answer very short. 0.41. What is the ratio of the Electricity production(% of total) in Georgia in 2005 to that in 2007?
Your answer should be compact. 3.15. What is the ratio of the Electricity production(% of total) of Honduras in 2005 to that in 2007?
Offer a terse response. 1.07. What is the ratio of the Electricity production(% of total) of Middle income in 2005 to that in 2008?
Your response must be concise. 1.28. What is the ratio of the Electricity production(% of total) in Costa Rica in 2005 to that in 2008?
Offer a terse response. 0.46. What is the ratio of the Electricity production(% of total) in Georgia in 2005 to that in 2008?
Offer a very short reply. 6.4. What is the ratio of the Electricity production(% of total) of Honduras in 2005 to that in 2008?
Provide a succinct answer. 1.08. What is the ratio of the Electricity production(% of total) of Middle income in 2005 to that in 2009?
Your answer should be very brief. 1.39. What is the ratio of the Electricity production(% of total) of Costa Rica in 2005 to that in 2009?
Keep it short and to the point. 0.68. What is the ratio of the Electricity production(% of total) of Georgia in 2005 to that in 2009?
Your answer should be compact. 1.99. What is the ratio of the Electricity production(% of total) in Honduras in 2005 to that in 2009?
Make the answer very short. 1.21. What is the ratio of the Electricity production(% of total) in Middle income in 2006 to that in 2007?
Your answer should be compact. 1.12. What is the ratio of the Electricity production(% of total) in Costa Rica in 2006 to that in 2007?
Your response must be concise. 0.77. What is the ratio of the Electricity production(% of total) in Georgia in 2006 to that in 2007?
Give a very brief answer. 1.14. What is the ratio of the Electricity production(% of total) of Honduras in 2006 to that in 2007?
Your answer should be very brief. 1.01. What is the ratio of the Electricity production(% of total) in Middle income in 2006 to that in 2008?
Keep it short and to the point. 1.15. What is the ratio of the Electricity production(% of total) of Costa Rica in 2006 to that in 2008?
Ensure brevity in your answer.  0.86. What is the ratio of the Electricity production(% of total) of Georgia in 2006 to that in 2008?
Keep it short and to the point. 2.32. What is the ratio of the Electricity production(% of total) of Honduras in 2006 to that in 2008?
Give a very brief answer. 1.02. What is the ratio of the Electricity production(% of total) in Middle income in 2006 to that in 2009?
Keep it short and to the point. 1.26. What is the ratio of the Electricity production(% of total) in Costa Rica in 2006 to that in 2009?
Your answer should be very brief. 1.27. What is the ratio of the Electricity production(% of total) in Georgia in 2006 to that in 2009?
Provide a succinct answer. 0.72. What is the ratio of the Electricity production(% of total) in Honduras in 2006 to that in 2009?
Offer a terse response. 1.14. What is the ratio of the Electricity production(% of total) of Middle income in 2007 to that in 2008?
Make the answer very short. 1.03. What is the ratio of the Electricity production(% of total) of Costa Rica in 2007 to that in 2008?
Provide a short and direct response. 1.12. What is the ratio of the Electricity production(% of total) in Georgia in 2007 to that in 2008?
Your answer should be very brief. 2.03. What is the ratio of the Electricity production(% of total) of Honduras in 2007 to that in 2008?
Your answer should be compact. 1.01. What is the ratio of the Electricity production(% of total) in Middle income in 2007 to that in 2009?
Your answer should be compact. 1.13. What is the ratio of the Electricity production(% of total) of Costa Rica in 2007 to that in 2009?
Give a very brief answer. 1.65. What is the ratio of the Electricity production(% of total) in Georgia in 2007 to that in 2009?
Give a very brief answer. 0.63. What is the ratio of the Electricity production(% of total) of Honduras in 2007 to that in 2009?
Your response must be concise. 1.13. What is the ratio of the Electricity production(% of total) of Middle income in 2008 to that in 2009?
Offer a very short reply. 1.09. What is the ratio of the Electricity production(% of total) in Costa Rica in 2008 to that in 2009?
Provide a short and direct response. 1.48. What is the ratio of the Electricity production(% of total) of Georgia in 2008 to that in 2009?
Your answer should be very brief. 0.31. What is the ratio of the Electricity production(% of total) in Honduras in 2008 to that in 2009?
Your answer should be compact. 1.12. What is the difference between the highest and the second highest Electricity production(% of total) in Middle income?
Your response must be concise. 0.15. What is the difference between the highest and the second highest Electricity production(% of total) in Costa Rica?
Make the answer very short. 0.83. What is the difference between the highest and the second highest Electricity production(% of total) of Georgia?
Offer a very short reply. 0.3. What is the difference between the highest and the second highest Electricity production(% of total) in Honduras?
Provide a short and direct response. 2.98. What is the difference between the highest and the lowest Electricity production(% of total) of Middle income?
Offer a very short reply. 2.85. What is the difference between the highest and the lowest Electricity production(% of total) of Costa Rica?
Your answer should be compact. 7.17. What is the difference between the highest and the lowest Electricity production(% of total) of Georgia?
Your answer should be very brief. 0.77. What is the difference between the highest and the lowest Electricity production(% of total) of Honduras?
Keep it short and to the point. 14.79. 